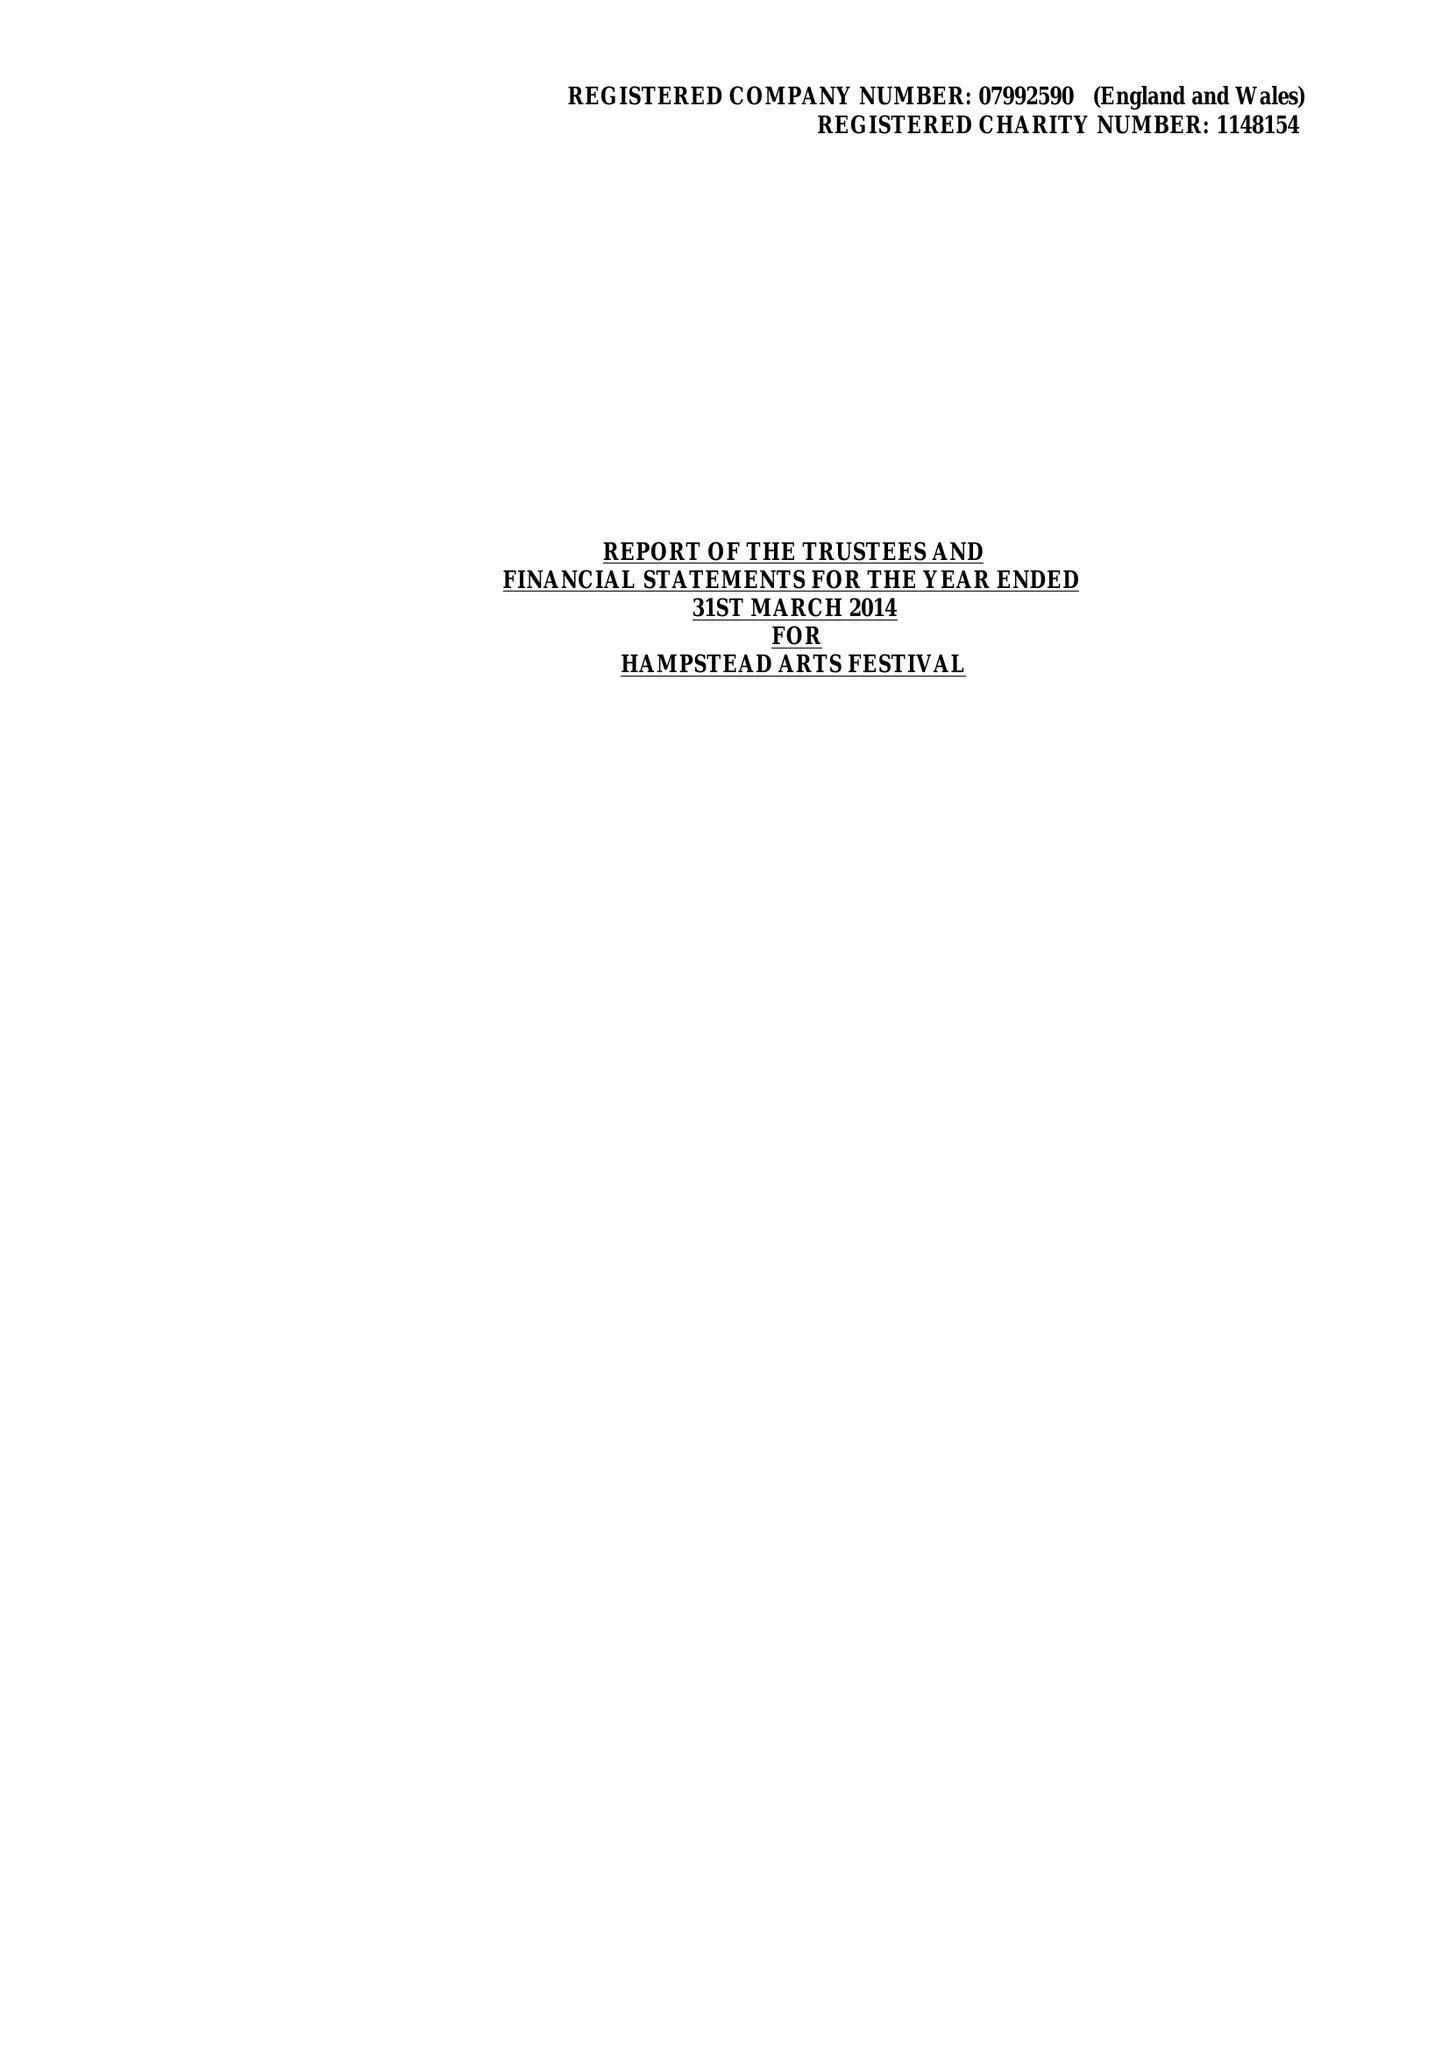What is the value for the charity_name?
Answer the question using a single word or phrase. Hampstead Arts Festival 